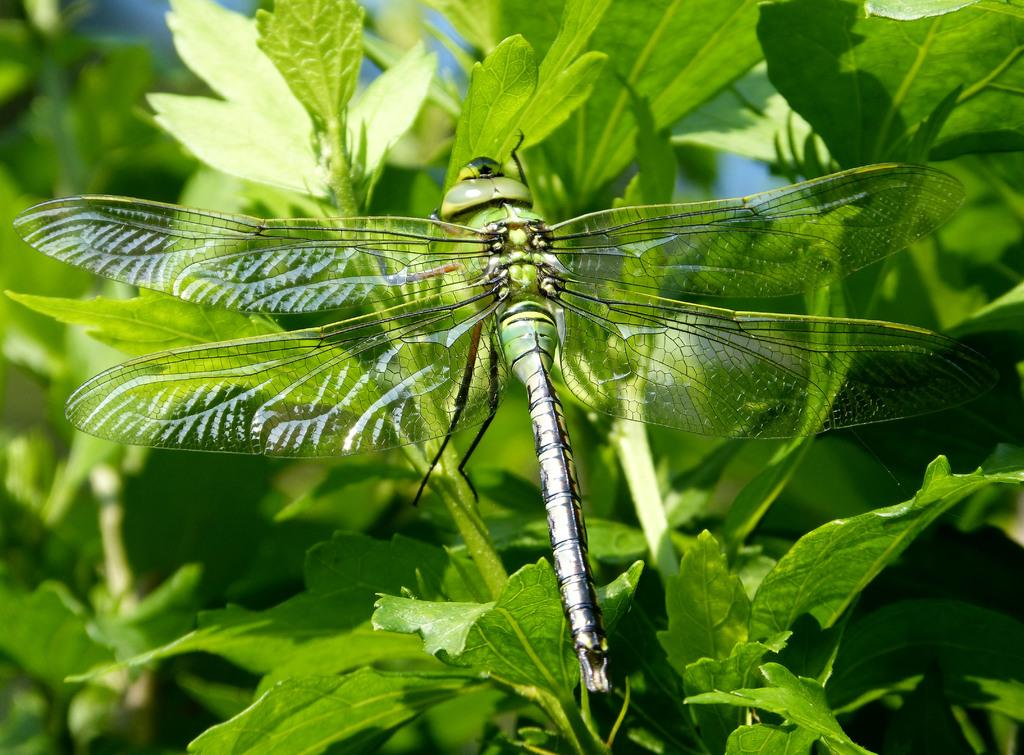What insect can be seen in the picture? There is a dragonfly in the picture. Where is the dragonfly located in the image? The dragonfly is on the leaves of a plant. What color are the leaves that the dragonfly is on? The leaves are green in color. How many stitches does the dragonfly have in its stomach in the image? There are no stitches visible on the dragonfly in the image, as dragonflies are insects and do not have stitches. 